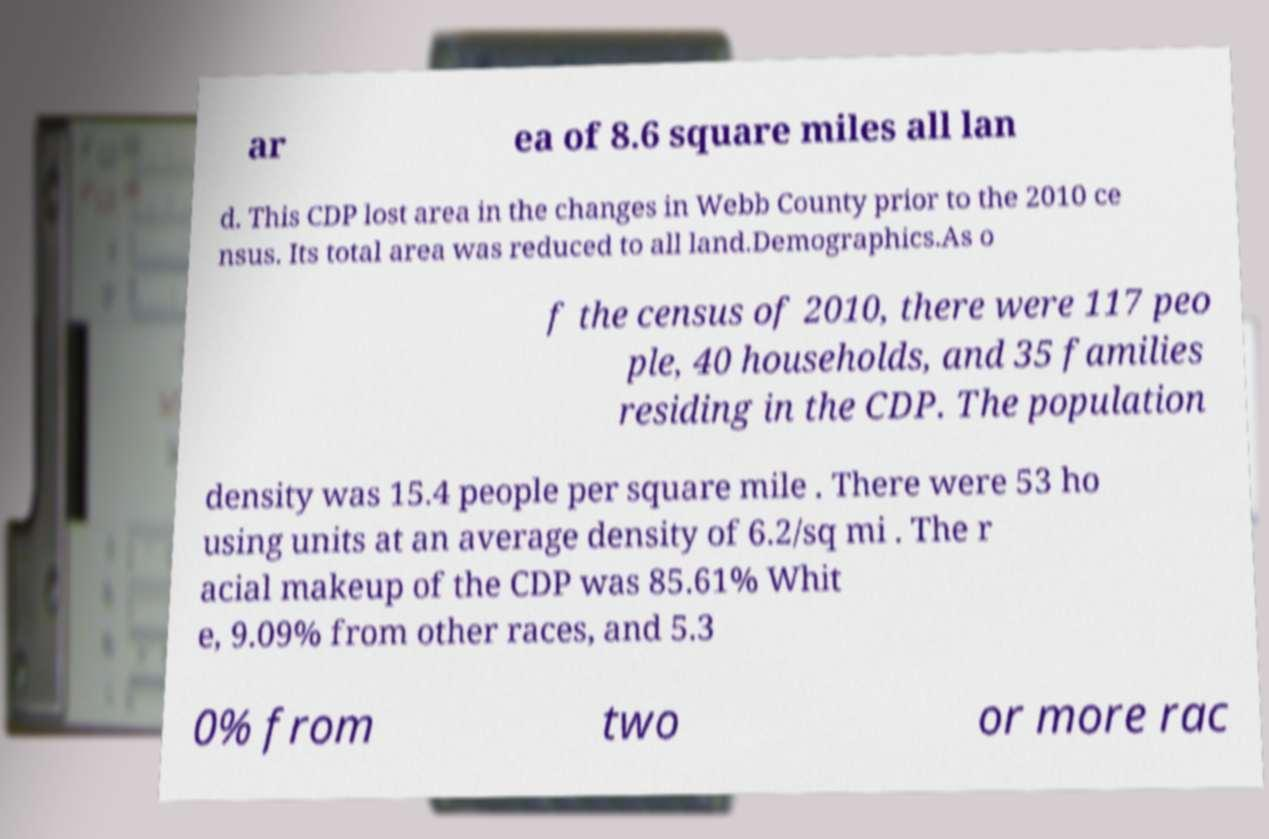There's text embedded in this image that I need extracted. Can you transcribe it verbatim? ar ea of 8.6 square miles all lan d. This CDP lost area in the changes in Webb County prior to the 2010 ce nsus. Its total area was reduced to all land.Demographics.As o f the census of 2010, there were 117 peo ple, 40 households, and 35 families residing in the CDP. The population density was 15.4 people per square mile . There were 53 ho using units at an average density of 6.2/sq mi . The r acial makeup of the CDP was 85.61% Whit e, 9.09% from other races, and 5.3 0% from two or more rac 